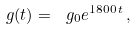Convert formula to latex. <formula><loc_0><loc_0><loc_500><loc_500>\ g ( t ) = \ g _ { 0 } e ^ { 1 8 0 0 \, t } \, ,</formula> 